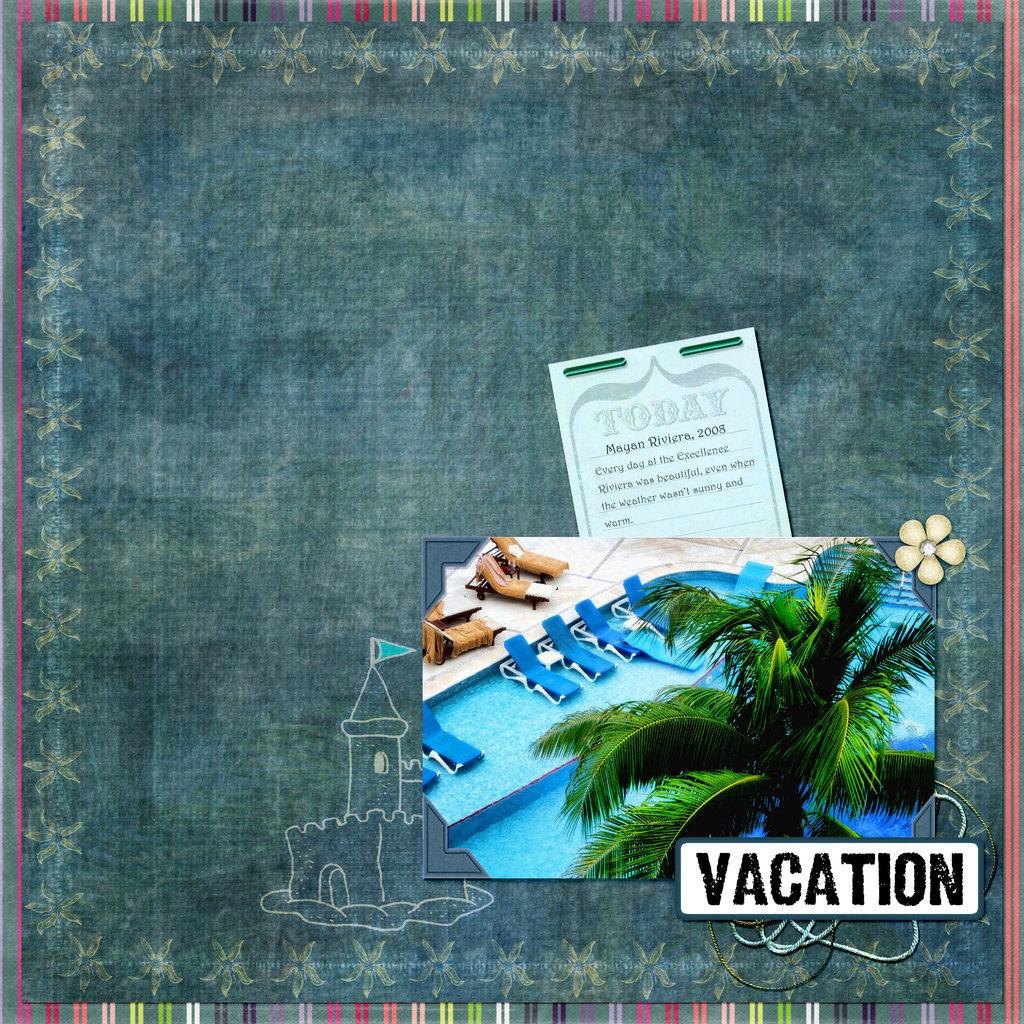What is the main object in the image? There is a board in the image. What other items can be seen on the board? There is a card, a photo, and a painting on the board. Is there any text or marking on the board? The image contains a watermark. How many beads are used to create the knot on the painting in the image? There is no knot or beads present in the painting in the image. Can you hear the person in the image crying? There is no person or indication of crying in the image. 